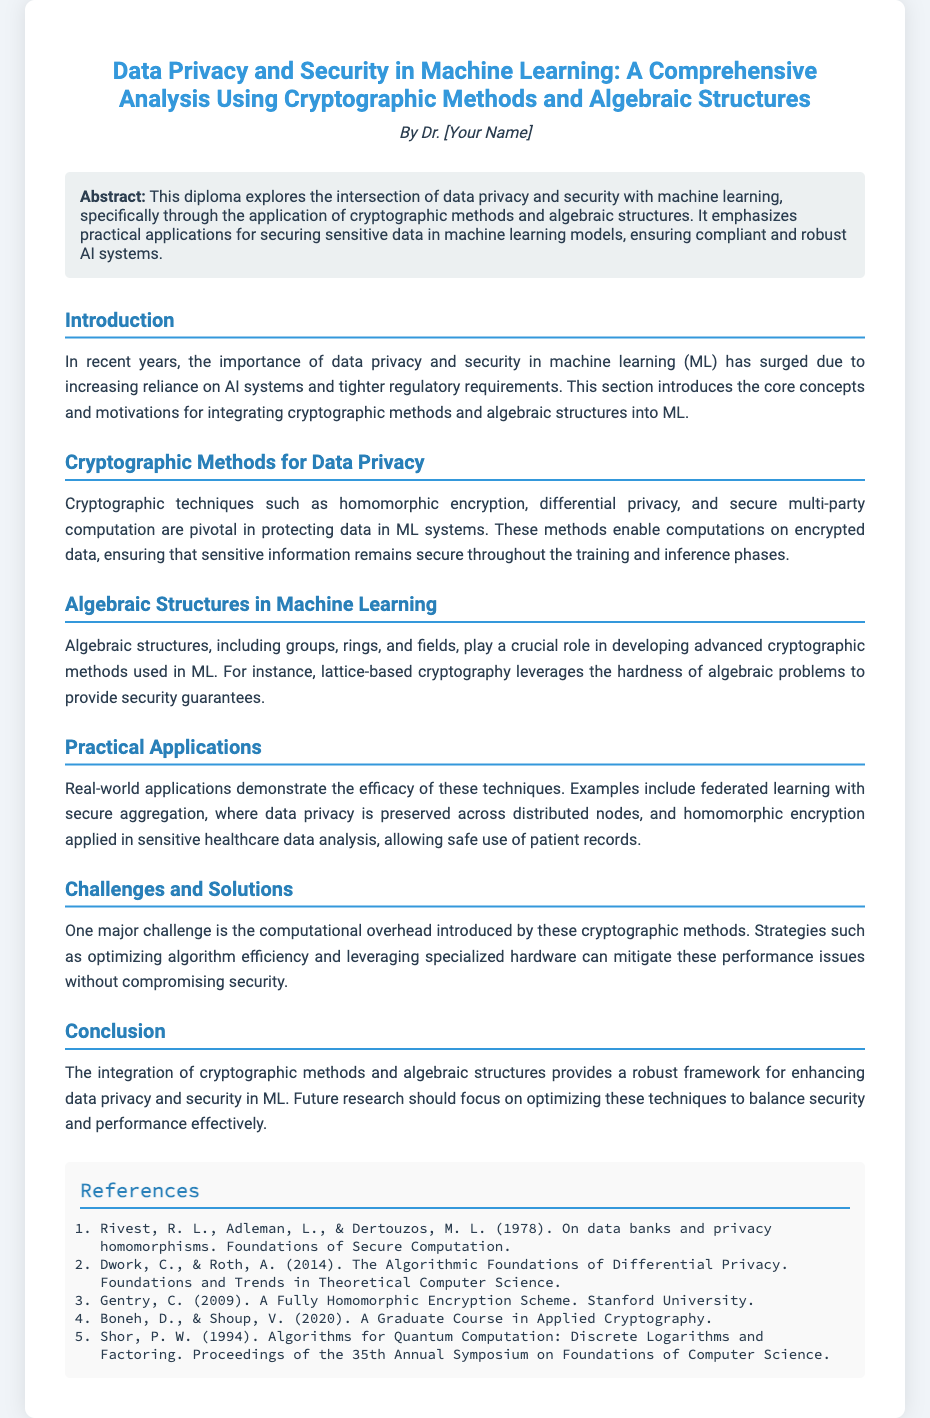What is the title of the diploma? The title is provided in the header section of the document, indicating the focus on data privacy and security in machine learning through cryptographic methods and algebraic structures.
Answer: Data Privacy and Security in Machine Learning: A Comprehensive Analysis Using Cryptographic Methods and Algebraic Structures Who is the author of the diploma? The author's name is mentioned in the header section, where it reads "By Dr. [Your Name]."
Answer: Dr. [Your Name] What cryptographic method is mentioned for protecting data in ML systems? The document lists specific cryptographic techniques such as homomorphic encryption, differential privacy, and secure multi-party computation as essential for data protection in machine learning.
Answer: Homomorphic encryption What algebraic structures are discussed in relation to cryptographic methods? The section on algebraic structures explains that groups, rings, and fields are significant for developing cryptographic methods used in ML.
Answer: Groups, rings, and fields What is a major challenge identified in using cryptographic methods? The document details that computational overhead is a significant challenge when applying cryptographic methods in machine learning models.
Answer: Computational overhead What does the diploma emphasize in the abstract? The abstract highlights the focus on practical applications for securing sensitive data in machine learning models, ensuring compliance and robustness in AI systems.
Answer: Securing sensitive data How many references are listed in the diploma? The references section presents a list that is counted to determine the total number of sources cited in the document.
Answer: 5 